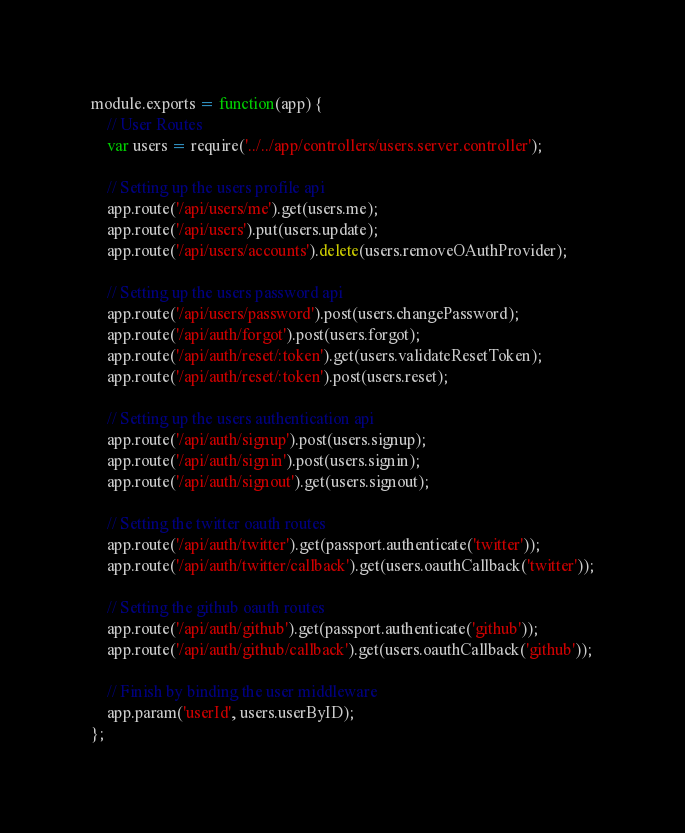Convert code to text. <code><loc_0><loc_0><loc_500><loc_500><_JavaScript_>module.exports = function(app) {
	// User Routes
	var users = require('../../app/controllers/users.server.controller');

	// Setting up the users profile api
	app.route('/api/users/me').get(users.me);
	app.route('/api/users').put(users.update);
	app.route('/api/users/accounts').delete(users.removeOAuthProvider);

	// Setting up the users password api
	app.route('/api/users/password').post(users.changePassword);
	app.route('/api/auth/forgot').post(users.forgot);
	app.route('/api/auth/reset/:token').get(users.validateResetToken);
	app.route('/api/auth/reset/:token').post(users.reset);

	// Setting up the users authentication api
	app.route('/api/auth/signup').post(users.signup);
	app.route('/api/auth/signin').post(users.signin);
	app.route('/api/auth/signout').get(users.signout);

	// Setting the twitter oauth routes
	app.route('/api/auth/twitter').get(passport.authenticate('twitter'));
	app.route('/api/auth/twitter/callback').get(users.oauthCallback('twitter'));

	// Setting the github oauth routes
	app.route('/api/auth/github').get(passport.authenticate('github'));
	app.route('/api/auth/github/callback').get(users.oauthCallback('github'));

	// Finish by binding the user middleware
	app.param('userId', users.userByID);
};</code> 